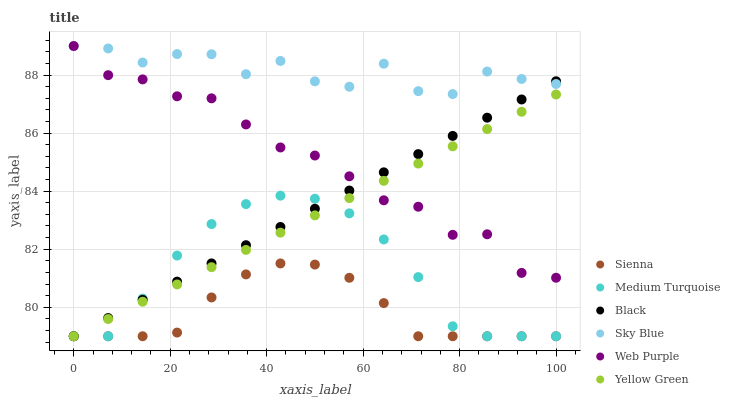Does Sienna have the minimum area under the curve?
Answer yes or no. Yes. Does Sky Blue have the maximum area under the curve?
Answer yes or no. Yes. Does Web Purple have the minimum area under the curve?
Answer yes or no. No. Does Web Purple have the maximum area under the curve?
Answer yes or no. No. Is Yellow Green the smoothest?
Answer yes or no. Yes. Is Sky Blue the roughest?
Answer yes or no. Yes. Is Sienna the smoothest?
Answer yes or no. No. Is Sienna the roughest?
Answer yes or no. No. Does Yellow Green have the lowest value?
Answer yes or no. Yes. Does Web Purple have the lowest value?
Answer yes or no. No. Does Sky Blue have the highest value?
Answer yes or no. Yes. Does Sienna have the highest value?
Answer yes or no. No. Is Sienna less than Sky Blue?
Answer yes or no. Yes. Is Sky Blue greater than Medium Turquoise?
Answer yes or no. Yes. Does Web Purple intersect Sky Blue?
Answer yes or no. Yes. Is Web Purple less than Sky Blue?
Answer yes or no. No. Is Web Purple greater than Sky Blue?
Answer yes or no. No. Does Sienna intersect Sky Blue?
Answer yes or no. No. 